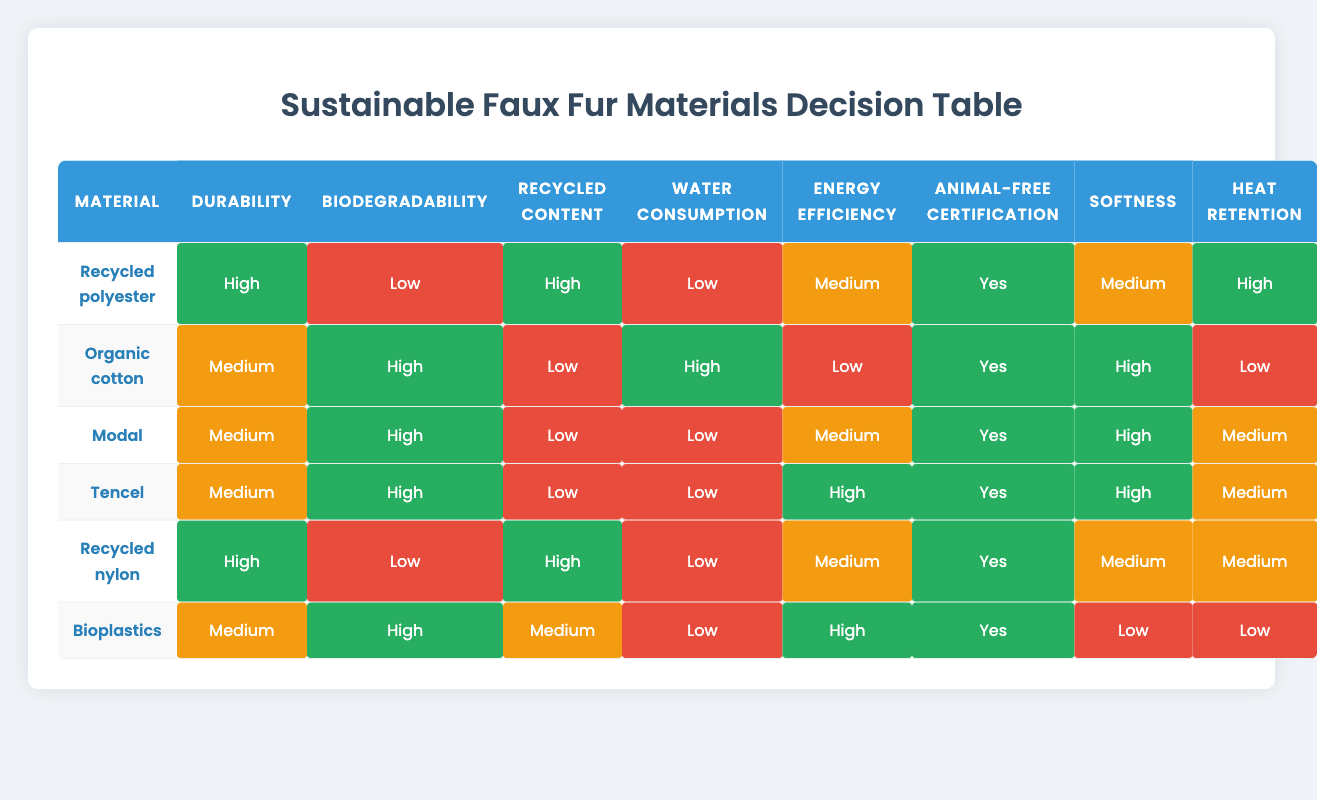What is the durability rating of recycled polyester? Referring to the table, the durability rating for recycled polyester is listed directly under the "Durability" column. It specifies "High."
Answer: High Which materials have a high biodegradability rating? To find materials with a high biodegradability rating, we look at the "Biodegradability" column and identify which rows contain "High." The materials that fit this criterion are Organic cotton, Modal, Tencel, and Bioplastics.
Answer: Organic cotton, Modal, Tencel, Bioplastics What is the average water consumption rating for the materials listed? We take the water consumption ratings for all materials: Low (2 times), High (2 times). We assign values: High = 2 and Low = 1. So, the sum is (2 + 1 + 1 + 1 + 1 + 1) = 7, and there are 6 materials, thus average = 7/6 ≈ 1.17. The corresponding rating would be Low, as it leans towards that category.
Answer: Low Is organic cotton animal-free certified? Checking the "Animal-free certification" column for organic cotton, it indicates "Yes." This confirms that organic cotton is certified as animal-free.
Answer: Yes Which material has the highest heat retention rating? To determine which material has the highest heat retention rating, we examine the "Heat retention" column. The ratings are: High (Recycled polyester), Medium (4 materials), and Low (Organic cotton, Bioplastics). The material with the highest is recycled polyester with a "High" rating.
Answer: Recycled polyester 